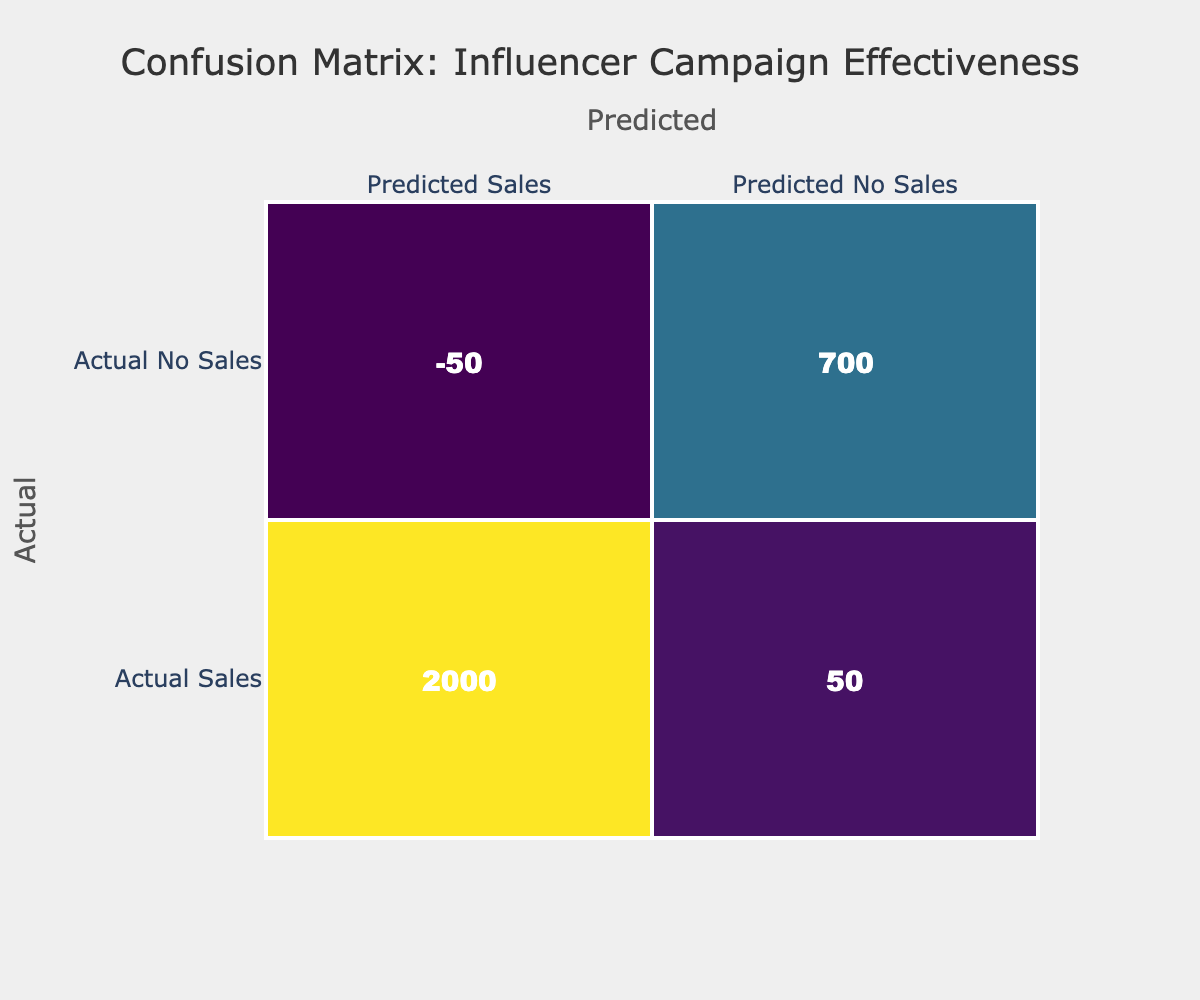What is the total number of actual sales recorded? By summing the values in the Actual Sales column (950 + 200 + 150 + 400 + 300), the total actual sales equals 2000.
Answer: 2000 What is the total number of predicted sales? The total predicted sales can be calculated by summing the values in the Predicted Sales column (900 + 180 + 160 + 420 + 290), resulting in a total of 1950 predicted sales.
Answer: 1950 What are the false negatives in this data? False negatives are calculated by subtracting the number of predicted sales from the actual sales. The total actual sales is 2000 and the predicted sales is 1950, so the false negatives equal 2000 - 1950 = 50.
Answer: 50 Is the number of true positives greater than true negatives? True positives are equal to the total actual sales, which is 2000; true negatives come from the Actual No Sales, which total 200. Since 2000 is greater than 200, the statement is true.
Answer: Yes What is the difference between the total actual sales and total predicted no sales? The total actual sales is 2000 and the total predicted no sales is calculated as (100 + 320 + 40 + 80 + 210) = 750. The difference is 2000 - 750 = 1250.
Answer: 1250 What percentage of predicted sales were accurate? To find the accurate predicted sales, we first need the true positives, which sum to 1950 (since the confusion matrix indicates they include actual sales). The percentage of accurate predicted sales is 1950 / (1950 + 50) * 100 = 96.15 percent.
Answer: 96.15 percent Are true positives and predicted sales the same number? True positives, in this case, are actually 950 (the first element of actual sales), while predicted sales is 900. Therefore, these numbers are not the same.
Answer: No What is the average number of predicted no sales across all campaigns? To get the average, add the values of predicted no sales (100 + 320 + 40 + 80 + 210 = 750) and divide by the number of campaigns, which is 5. So, 750 / 5 = 150.
Answer: 150 What can be inferred about the influencer campaign effectiveness based on the confusion matrix? Looking at the confusion matrix, if the number of actual sales significantly exceeds the predicted sales, it indicates that the campaigns are effectively driving sales. However, given that the predicted sales are slightly lower than actual sales, this points to a generally successful campaign with room for optimization.
Answer: Effective but needs optimization 